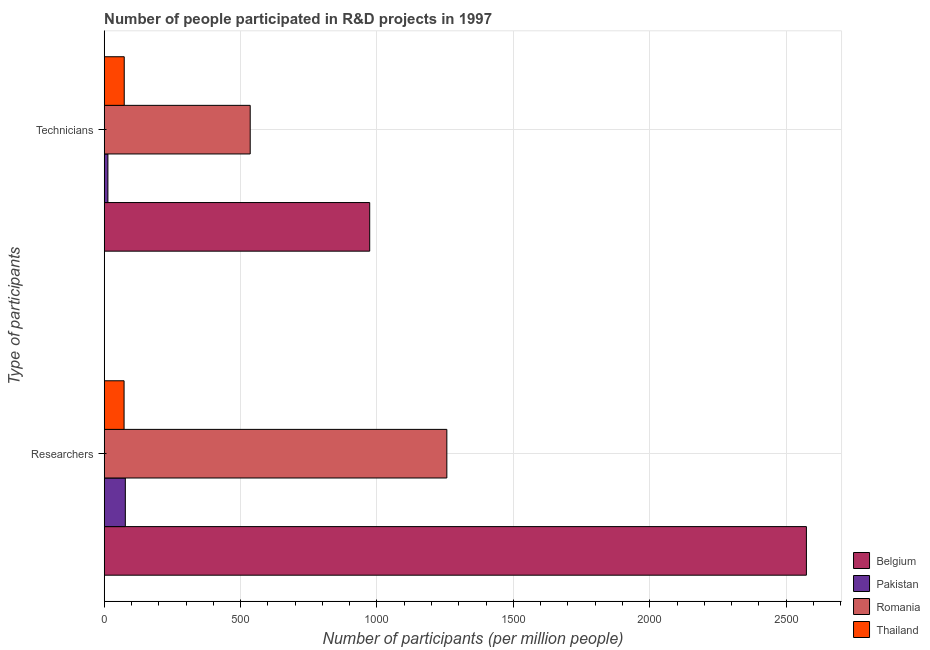How many groups of bars are there?
Your answer should be compact. 2. Are the number of bars on each tick of the Y-axis equal?
Your answer should be compact. Yes. How many bars are there on the 1st tick from the top?
Your answer should be compact. 4. How many bars are there on the 1st tick from the bottom?
Your response must be concise. 4. What is the label of the 2nd group of bars from the top?
Offer a terse response. Researchers. What is the number of technicians in Belgium?
Keep it short and to the point. 973.33. Across all countries, what is the maximum number of researchers?
Your answer should be compact. 2574.35. Across all countries, what is the minimum number of researchers?
Offer a very short reply. 72.82. What is the total number of technicians in the graph?
Your answer should be very brief. 1595.57. What is the difference between the number of researchers in Belgium and that in Romania?
Your answer should be compact. 1318.2. What is the difference between the number of technicians in Pakistan and the number of researchers in Romania?
Provide a short and direct response. -1242.58. What is the average number of researchers per country?
Keep it short and to the point. 995.19. What is the difference between the number of researchers and number of technicians in Pakistan?
Keep it short and to the point. 63.86. What is the ratio of the number of technicians in Romania to that in Thailand?
Your answer should be compact. 7.29. Is the number of researchers in Romania less than that in Belgium?
Offer a very short reply. Yes. In how many countries, is the number of researchers greater than the average number of researchers taken over all countries?
Offer a terse response. 2. What does the 3rd bar from the bottom in Researchers represents?
Provide a succinct answer. Romania. How many bars are there?
Keep it short and to the point. 8. Are all the bars in the graph horizontal?
Provide a short and direct response. Yes. What is the difference between two consecutive major ticks on the X-axis?
Offer a terse response. 500. Does the graph contain grids?
Keep it short and to the point. Yes. Where does the legend appear in the graph?
Provide a succinct answer. Bottom right. How are the legend labels stacked?
Provide a succinct answer. Vertical. What is the title of the graph?
Keep it short and to the point. Number of people participated in R&D projects in 1997. Does "Barbados" appear as one of the legend labels in the graph?
Ensure brevity in your answer.  No. What is the label or title of the X-axis?
Make the answer very short. Number of participants (per million people). What is the label or title of the Y-axis?
Keep it short and to the point. Type of participants. What is the Number of participants (per million people) of Belgium in Researchers?
Provide a succinct answer. 2574.35. What is the Number of participants (per million people) of Pakistan in Researchers?
Ensure brevity in your answer.  77.43. What is the Number of participants (per million people) in Romania in Researchers?
Provide a short and direct response. 1256.15. What is the Number of participants (per million people) of Thailand in Researchers?
Your answer should be very brief. 72.82. What is the Number of participants (per million people) in Belgium in Technicians?
Your answer should be compact. 973.33. What is the Number of participants (per million people) in Pakistan in Technicians?
Provide a short and direct response. 13.57. What is the Number of participants (per million people) of Romania in Technicians?
Keep it short and to the point. 535.23. What is the Number of participants (per million people) in Thailand in Technicians?
Provide a short and direct response. 73.43. Across all Type of participants, what is the maximum Number of participants (per million people) in Belgium?
Give a very brief answer. 2574.35. Across all Type of participants, what is the maximum Number of participants (per million people) of Pakistan?
Offer a very short reply. 77.43. Across all Type of participants, what is the maximum Number of participants (per million people) in Romania?
Make the answer very short. 1256.15. Across all Type of participants, what is the maximum Number of participants (per million people) in Thailand?
Provide a succinct answer. 73.43. Across all Type of participants, what is the minimum Number of participants (per million people) in Belgium?
Keep it short and to the point. 973.33. Across all Type of participants, what is the minimum Number of participants (per million people) of Pakistan?
Your answer should be compact. 13.57. Across all Type of participants, what is the minimum Number of participants (per million people) of Romania?
Provide a succinct answer. 535.23. Across all Type of participants, what is the minimum Number of participants (per million people) of Thailand?
Offer a very short reply. 72.82. What is the total Number of participants (per million people) in Belgium in the graph?
Your response must be concise. 3547.69. What is the total Number of participants (per million people) of Pakistan in the graph?
Ensure brevity in your answer.  91.01. What is the total Number of participants (per million people) in Romania in the graph?
Provide a succinct answer. 1791.38. What is the total Number of participants (per million people) of Thailand in the graph?
Offer a very short reply. 146.25. What is the difference between the Number of participants (per million people) of Belgium in Researchers and that in Technicians?
Offer a very short reply. 1601.02. What is the difference between the Number of participants (per million people) of Pakistan in Researchers and that in Technicians?
Provide a succinct answer. 63.86. What is the difference between the Number of participants (per million people) in Romania in Researchers and that in Technicians?
Provide a short and direct response. 720.93. What is the difference between the Number of participants (per million people) in Thailand in Researchers and that in Technicians?
Your answer should be very brief. -0.61. What is the difference between the Number of participants (per million people) of Belgium in Researchers and the Number of participants (per million people) of Pakistan in Technicians?
Give a very brief answer. 2560.78. What is the difference between the Number of participants (per million people) of Belgium in Researchers and the Number of participants (per million people) of Romania in Technicians?
Give a very brief answer. 2039.12. What is the difference between the Number of participants (per million people) of Belgium in Researchers and the Number of participants (per million people) of Thailand in Technicians?
Your answer should be very brief. 2500.92. What is the difference between the Number of participants (per million people) of Pakistan in Researchers and the Number of participants (per million people) of Romania in Technicians?
Ensure brevity in your answer.  -457.79. What is the difference between the Number of participants (per million people) in Pakistan in Researchers and the Number of participants (per million people) in Thailand in Technicians?
Keep it short and to the point. 4. What is the difference between the Number of participants (per million people) of Romania in Researchers and the Number of participants (per million people) of Thailand in Technicians?
Give a very brief answer. 1182.72. What is the average Number of participants (per million people) of Belgium per Type of participants?
Make the answer very short. 1773.84. What is the average Number of participants (per million people) of Pakistan per Type of participants?
Your answer should be compact. 45.5. What is the average Number of participants (per million people) of Romania per Type of participants?
Keep it short and to the point. 895.69. What is the average Number of participants (per million people) in Thailand per Type of participants?
Offer a very short reply. 73.13. What is the difference between the Number of participants (per million people) in Belgium and Number of participants (per million people) in Pakistan in Researchers?
Provide a succinct answer. 2496.92. What is the difference between the Number of participants (per million people) of Belgium and Number of participants (per million people) of Romania in Researchers?
Offer a terse response. 1318.2. What is the difference between the Number of participants (per million people) in Belgium and Number of participants (per million people) in Thailand in Researchers?
Make the answer very short. 2501.53. What is the difference between the Number of participants (per million people) of Pakistan and Number of participants (per million people) of Romania in Researchers?
Make the answer very short. -1178.72. What is the difference between the Number of participants (per million people) in Pakistan and Number of participants (per million people) in Thailand in Researchers?
Your answer should be very brief. 4.61. What is the difference between the Number of participants (per million people) of Romania and Number of participants (per million people) of Thailand in Researchers?
Your answer should be compact. 1183.33. What is the difference between the Number of participants (per million people) in Belgium and Number of participants (per million people) in Pakistan in Technicians?
Offer a very short reply. 959.76. What is the difference between the Number of participants (per million people) of Belgium and Number of participants (per million people) of Romania in Technicians?
Your answer should be very brief. 438.11. What is the difference between the Number of participants (per million people) in Belgium and Number of participants (per million people) in Thailand in Technicians?
Your answer should be compact. 899.9. What is the difference between the Number of participants (per million people) in Pakistan and Number of participants (per million people) in Romania in Technicians?
Provide a short and direct response. -521.65. What is the difference between the Number of participants (per million people) of Pakistan and Number of participants (per million people) of Thailand in Technicians?
Offer a terse response. -59.86. What is the difference between the Number of participants (per million people) in Romania and Number of participants (per million people) in Thailand in Technicians?
Give a very brief answer. 461.79. What is the ratio of the Number of participants (per million people) of Belgium in Researchers to that in Technicians?
Your response must be concise. 2.64. What is the ratio of the Number of participants (per million people) of Pakistan in Researchers to that in Technicians?
Offer a terse response. 5.7. What is the ratio of the Number of participants (per million people) of Romania in Researchers to that in Technicians?
Your response must be concise. 2.35. What is the difference between the highest and the second highest Number of participants (per million people) of Belgium?
Provide a succinct answer. 1601.02. What is the difference between the highest and the second highest Number of participants (per million people) of Pakistan?
Your answer should be very brief. 63.86. What is the difference between the highest and the second highest Number of participants (per million people) in Romania?
Offer a very short reply. 720.93. What is the difference between the highest and the second highest Number of participants (per million people) in Thailand?
Provide a succinct answer. 0.61. What is the difference between the highest and the lowest Number of participants (per million people) in Belgium?
Your answer should be very brief. 1601.02. What is the difference between the highest and the lowest Number of participants (per million people) in Pakistan?
Your answer should be compact. 63.86. What is the difference between the highest and the lowest Number of participants (per million people) of Romania?
Offer a terse response. 720.93. What is the difference between the highest and the lowest Number of participants (per million people) of Thailand?
Provide a succinct answer. 0.61. 